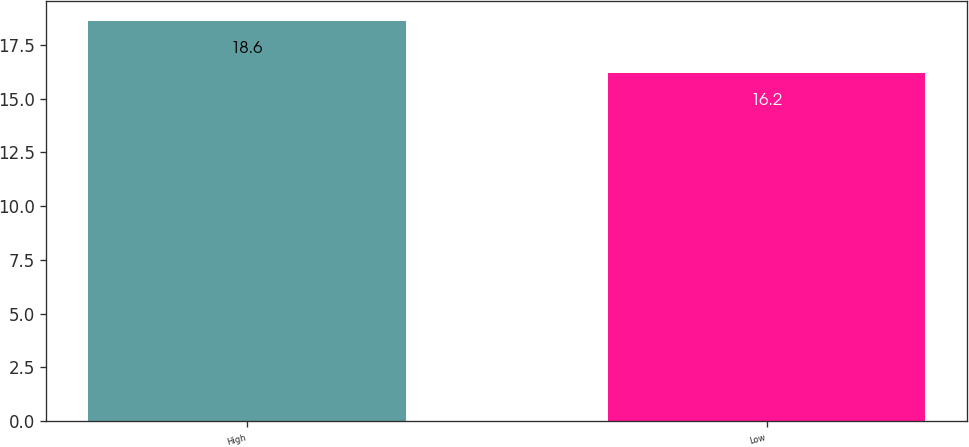<chart> <loc_0><loc_0><loc_500><loc_500><bar_chart><fcel>High<fcel>Low<nl><fcel>18.6<fcel>16.2<nl></chart> 